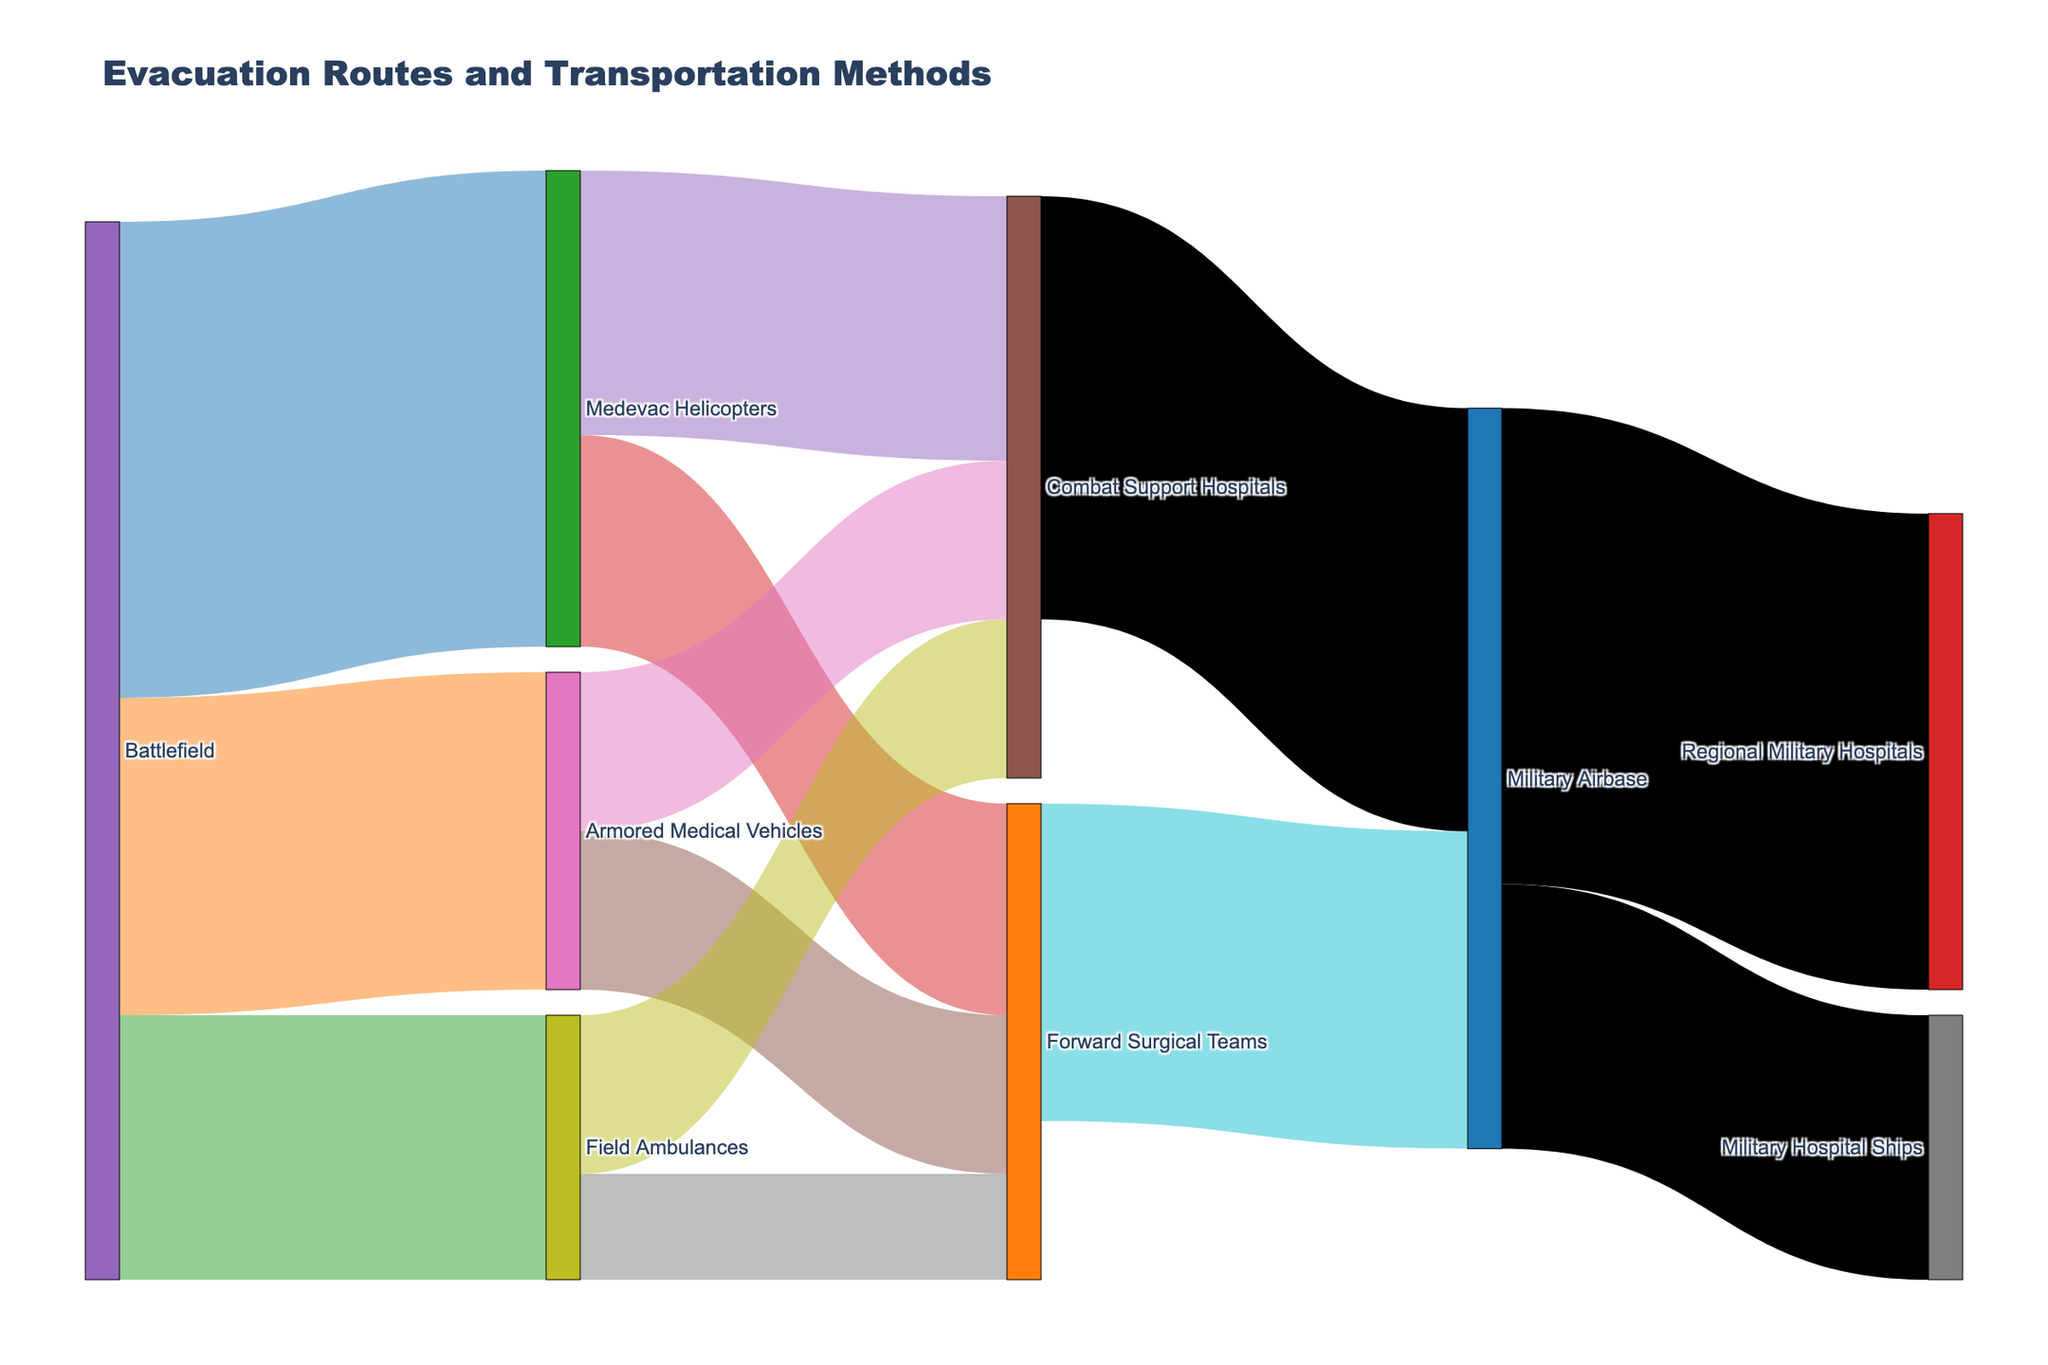What is the title of the figure? The title of the figure is found at the top of the plot and it states the main topic of the visual.
Answer: "Evacuation Routes and Transportation Methods" Which transportation method has the highest value from the Battlefield to another category? Observing the values next to the connecting paths from the Battlefield to transportation methods, Medevac Helicopters have the highest value with 450.
Answer: Medevac Helicopters How many total personnel are transported from the Battlefield? Sum all the values leading out from the Battlefield: 450 (Medevac Helicopters) + 300 (Armored Medical Vehicles) + 250 (Field Ambulances) = 1000.
Answer: 1000 What is the combined value of personnel transported to Combat Support Hospitals from all sources? Adding up the values leading to Combat Support Hospitals: 250 (from Medevac Helicopters) + 150 (from Armored Medical Vehicles) + 150 (from Field Ambulances) = 550.
Answer: 550 Which destination in the Sankey diagram receives the highest total number of personnel from all sources combined? Calculate the total for each destination: 
- Military Airbase: 300 (Forward Surgical Teams) + 400 (Combat Support Hospitals) = 700
- Military Hospital Ships: 250 (from Military Airbase) = 250
- Regional Military Hospitals: 450 (from Military Airbase) = 450
Hence, Military Airbase receives the highest total.
Answer: Military Airbase What is the value of personnel transported from Military Airbase to Military Hospital Ships? Find the specific path from Military Airbase to Military Hospital Ships and read the value, which is 250.
Answer: 250 What proportion of personnel are transported from the Military Airbase to Regional Military Hospitals compared to the total transported from Military Airbase? Calculate the proportion: 450 (to Regional Military Hospitals) / 700 (total from Military Airbase: 250 to Ships + 450 to Hospitals) = 450/700 = 0.64.
Answer: 0.64 Comparing Forward Surgical Teams and Combat Support Hospitals, which receives more personnel from Armored Medical Vehicles? By comparing the values: Forward Surgical Teams receive 150 and Combat Support Hospitals also receive 150 from Armored Medical Vehicles. They are equal.
Answer: Equal How does the flow of personnel from the Battlefield to Field Ambulances compare to the flow to Armored Medical Vehicles? The values indicate that 250 personnel are transported to Field Ambulances compared to 300 to Armored Medical Vehicles, so the flow to Field Ambulances is less.
Answer: Less What is the total number of personnel that ultimately reach Regional Military Hospitals? The only path to Regional Military Hospitals is from the Military Airbase, with a value of 450.
Answer: 450 